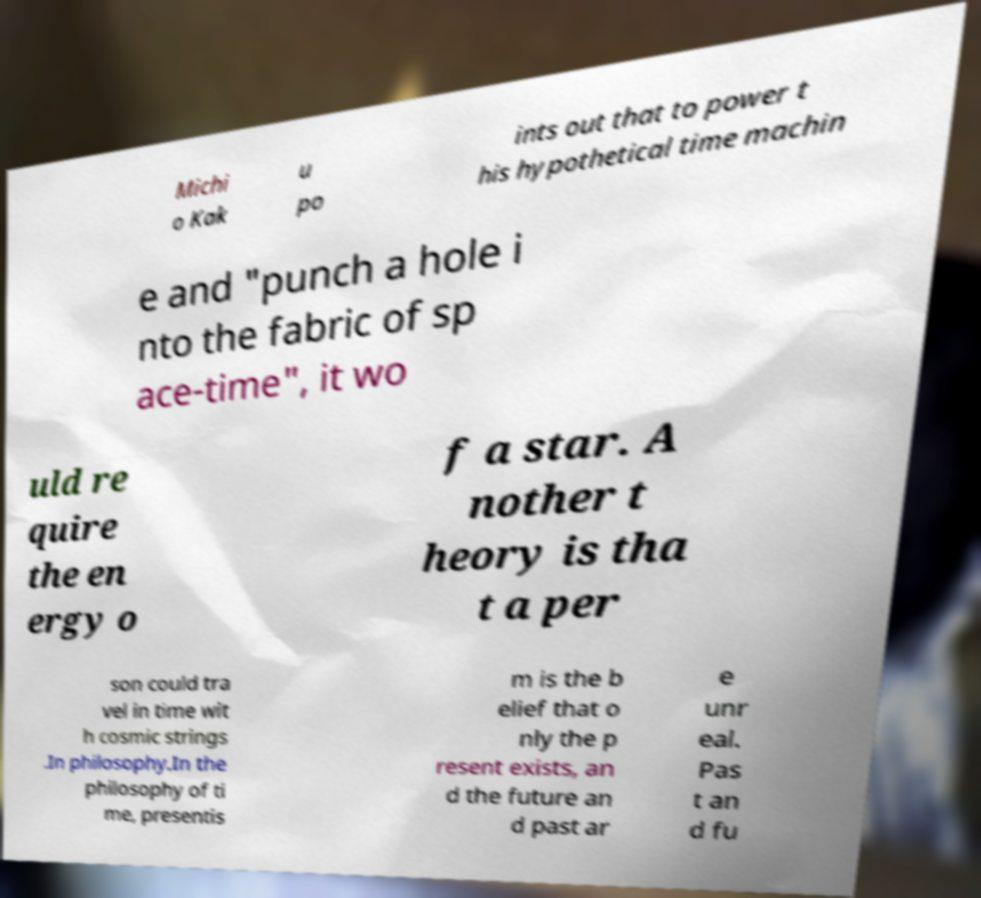Please identify and transcribe the text found in this image. Michi o Kak u po ints out that to power t his hypothetical time machin e and "punch a hole i nto the fabric of sp ace-time", it wo uld re quire the en ergy o f a star. A nother t heory is tha t a per son could tra vel in time wit h cosmic strings .In philosophy.In the philosophy of ti me, presentis m is the b elief that o nly the p resent exists, an d the future an d past ar e unr eal. Pas t an d fu 